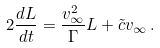Convert formula to latex. <formula><loc_0><loc_0><loc_500><loc_500>2 \frac { d L } { d t } = \frac { v _ { \infty } ^ { 2 } } { \Gamma } L + { \tilde { c } } v _ { \infty } \, .</formula> 